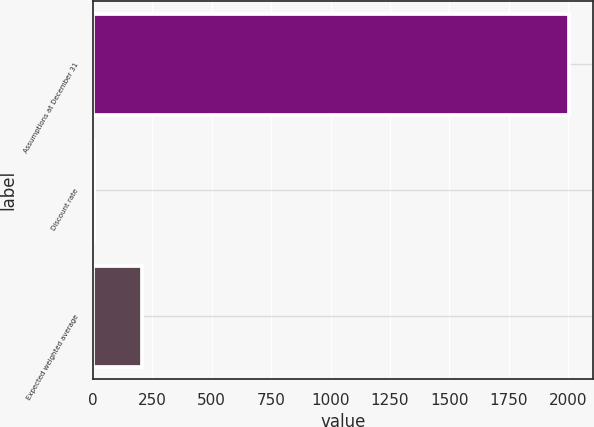Convert chart. <chart><loc_0><loc_0><loc_500><loc_500><bar_chart><fcel>Assumptions at December 31<fcel>Discount rate<fcel>Expected weighted average<nl><fcel>2004<fcel>5.95<fcel>205.75<nl></chart> 